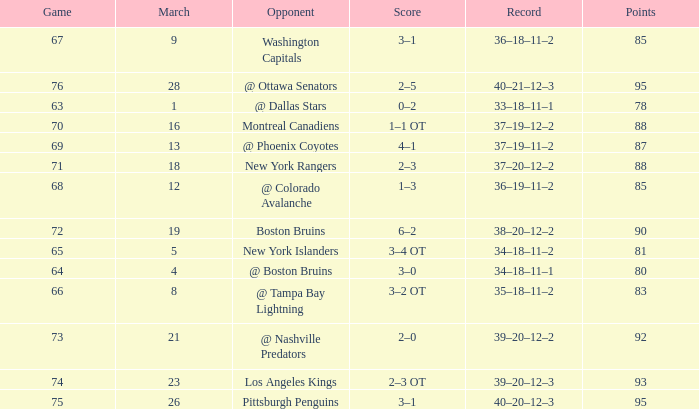Which Opponent has a Record of 38–20–12–2? Boston Bruins. 